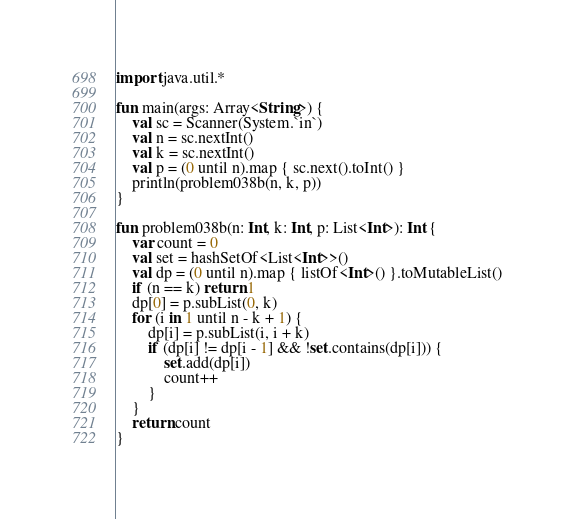Convert code to text. <code><loc_0><loc_0><loc_500><loc_500><_Kotlin_>import java.util.*

fun main(args: Array<String>) {
    val sc = Scanner(System.`in`)
    val n = sc.nextInt()
    val k = sc.nextInt()
    val p = (0 until n).map { sc.next().toInt() }
    println(problem038b(n, k, p))
}

fun problem038b(n: Int, k: Int, p: List<Int>): Int {
    var count = 0
    val set = hashSetOf<List<Int>>()
    val dp = (0 until n).map { listOf<Int>() }.toMutableList()
    if (n == k) return 1
    dp[0] = p.subList(0, k)
    for (i in 1 until n - k + 1) {
        dp[i] = p.subList(i, i + k)
        if (dp[i] != dp[i - 1] && !set.contains(dp[i])) {
            set.add(dp[i])
            count++
        }
    }
    return count
}</code> 